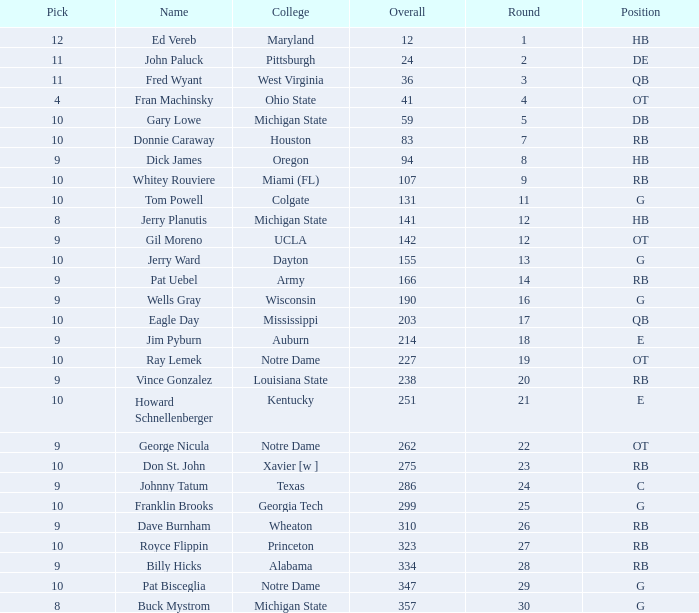What is the overall pick number for a draft pick smaller than 9, named buck mystrom from Michigan State college? 357.0. 